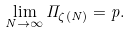Convert formula to latex. <formula><loc_0><loc_0><loc_500><loc_500>\lim _ { N \to \infty } \Pi _ { \zeta ( N ) } = p .</formula> 